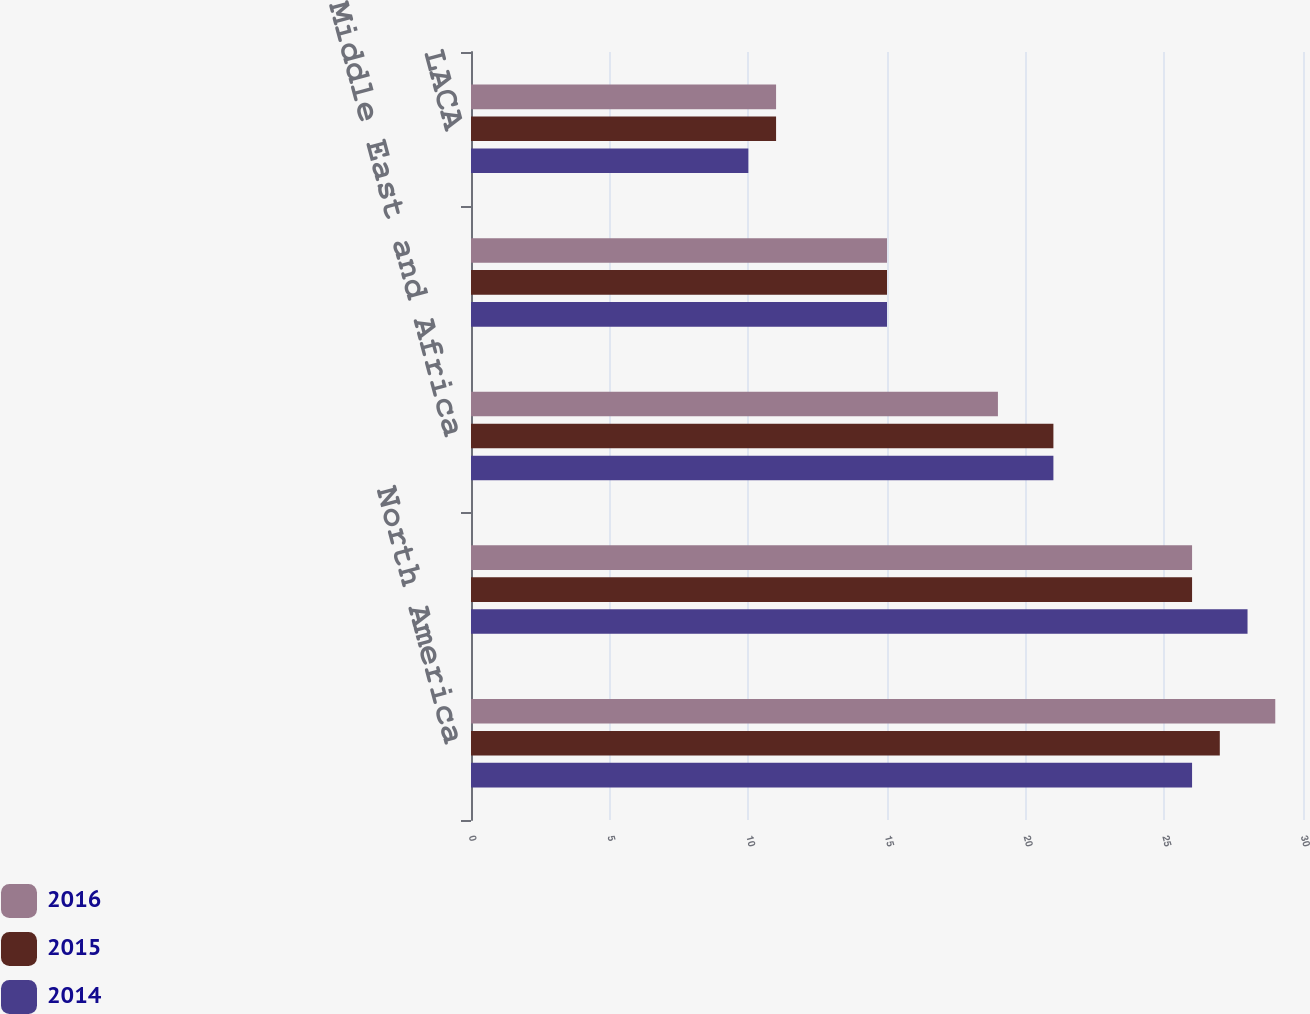<chart> <loc_0><loc_0><loc_500><loc_500><stacked_bar_chart><ecel><fcel>North America<fcel>Europe and CIS<fcel>Middle East and Africa<fcel>APAC<fcel>LACA<nl><fcel>2016<fcel>29<fcel>26<fcel>19<fcel>15<fcel>11<nl><fcel>2015<fcel>27<fcel>26<fcel>21<fcel>15<fcel>11<nl><fcel>2014<fcel>26<fcel>28<fcel>21<fcel>15<fcel>10<nl></chart> 